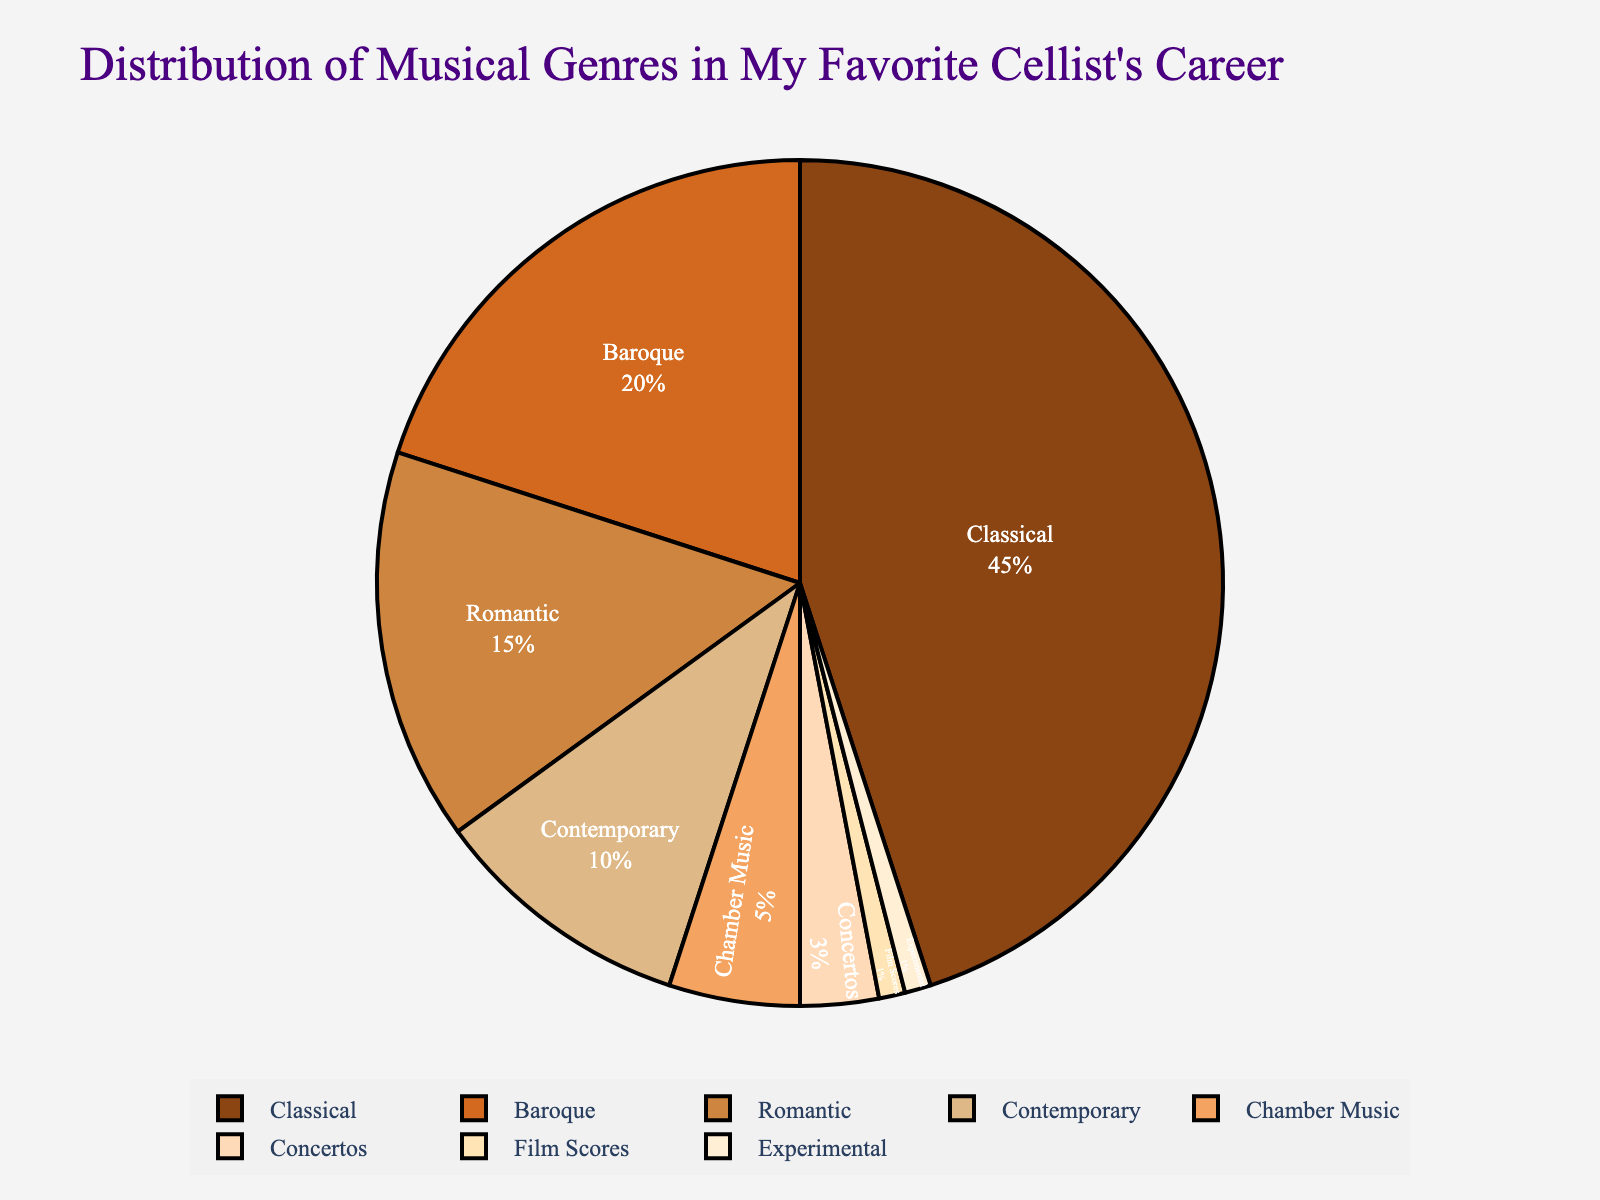What genre does the cellist perform most frequently? The genre with the highest percentage in the pie chart is Classical, representing 45% of the total performances.
Answer: Classical Which two genres together make up 35% of the performances? The two genres that add up to 35% are Baroque (20%) and Romantic (15%). Adding these two percentages gives us 20% + 15% = 35%.
Answer: Baroque and Romantic How much more frequently does the cellist perform Classical music compared to Romantic music? Classical music is performed 45% of the time, while Romantic is performed 15% of the time. The difference is 45% - 15% = 30%.
Answer: 30% What is the total percentage of the performances that is dedicated to Contemporary, Chamber Music, Concertos, Film Scores, and Experimental music combined? Add the percentages for Contemporary (10%), Chamber Music (5%), Concertos (3%), Film Scores (1%), and Experimental (1%): 10% + 5% + 3% + 1% + 1% = 20%.
Answer: 20% Which genre is performed equally as often as Chamber Music? Both Chamber Music and Experimental music make up 1% of the performances.
Answer: Experimental Does the cellist perform Baroque music more often than Romantic music? The pie chart shows that Baroque music is performed 20% of the time, whereas Romantic music is performed 15% of the time. Since 20% is greater than 15%, Baroque music is performed more often.
Answer: Yes What is the median value for the performance percentages? To find the median, we order the percentages and choose the middle number(s). Ordered percentages are: 1%, 1%, 3%, 5%, 10%, 15%, 20%, 45%. The middle numbers are 10% and 15%, so the median is the average: (10% + 15%) / 2 = 12.5%.
Answer: 12.5% Which genre is represented by the color closest to red in the pie chart? From the provided color palette, the color closest to red is '#D2691E' (a shade of brown), which corresponds to Baroque music.
Answer: Baroque What percentage of performances are non-Classical genres combined? Excluding Classical (45%), we sum all other percentages: 20% + 15% + 10% + 5% + 3% + 1% + 1% = 55%.
Answer: 55% 